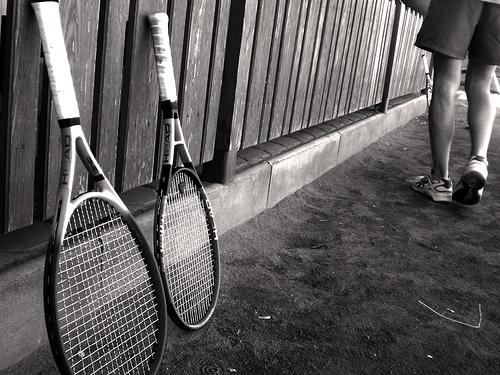What can be inferred about the label on the tennis racket? The label on the tennis racket is white. Determine whether the floor is dirty or of another hue. The floor is grey color and also appears dusty. Mention the attire of the individual and what they're doing in the image. A person wearing shorts and sneakers is walking. What kind of ambience does the image evoke? Specify the time. It's a daytime picture with a casual ambiance. Identify the object behind the person. There is a racket behind the person. What is the color of the tennis rackets in the image? The tennis rackets are black and white. Quantify the number of tennis rackets present and indicate their position. There are two tennis rackets leaning on a wall. Evaluate the overall quality of the image. The image is a black and white picture with clearly identifiable objects. How many tennis rackets are leaning on the fence? There are two tennis rackets leaning on the fence. Analyze the fence construction and identify its material. The fence is made of wood and has a pole in it. Observe the image and determine if the ground appears to be dusty or wet. Dusty In a casual and informal way, describe the scene in the image. There's a black and white pic of a tennis court with two rackets and a wooden fence. A dude in shorts is walking and he's got white shoes on. Which leg of the man is lifted? Unable to determine with the given data Choose the most suitable description for the image: b) A day time scene of a tennis court with a man walking and two tennis rackets leaning on a wooden fence What type of shoes is the man wearing? White shoes, possibly sneakers Determine the type of floor in the image. Grey What color is the tape on the handle of the tennis racket? White What does the label on the tennis racket say? Unable to determine as the text is not provided Write a factual sentence about the tennis rackets in the image. There are two tennis rackets leaning on a wooden fence, both black and white with white tape on their handles. Which outdoor sports activity is being represented in the image? Tennis Identify the time of day as shown in the photograph. Day time Please give a detailed description of the tennis rackets. There are two tennis rackets leaning on a wall, with black and white colors and white tape wrapped around their handles. How many tennis rackets are there by the fence? Two What material is the fence in the image made of? Wood Describe the man's attire in the photograph. The man is wearing shorts and white shoes. Select the correct statement from the following options: b) The man is wearing flip flops. 